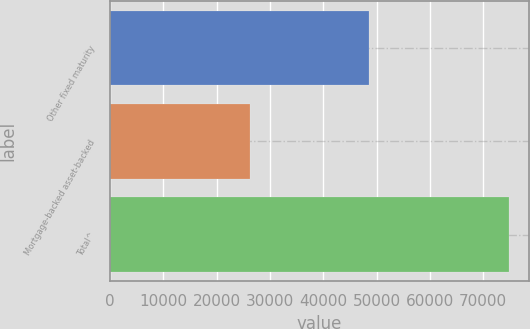Convert chart. <chart><loc_0><loc_0><loc_500><loc_500><bar_chart><fcel>Other fixed maturity<fcel>Mortgage-backed asset-backed<fcel>Total^<nl><fcel>48550<fcel>26240<fcel>74790<nl></chart> 